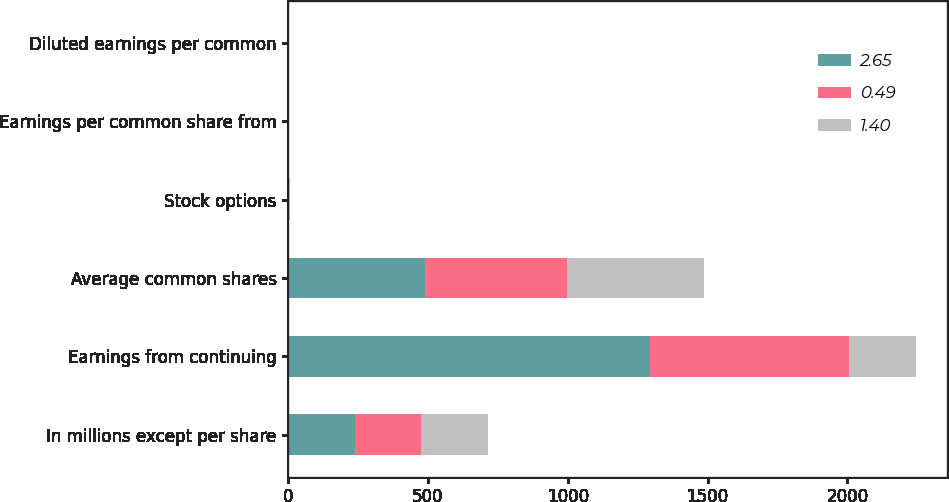<chart> <loc_0><loc_0><loc_500><loc_500><stacked_bar_chart><ecel><fcel>In millions except per share<fcel>Earnings from continuing<fcel>Average common shares<fcel>Stock options<fcel>Earnings per common share from<fcel>Diluted earnings per common<nl><fcel>2.65<fcel>238<fcel>1295<fcel>488.7<fcel>0.2<fcel>2.69<fcel>2.65<nl><fcel>0.49<fcel>238<fcel>711<fcel>509.7<fcel>2.9<fcel>1.41<fcel>1.4<nl><fcel>1.4<fcel>238<fcel>238<fcel>488.4<fcel>2.6<fcel>0.49<fcel>0.49<nl></chart> 